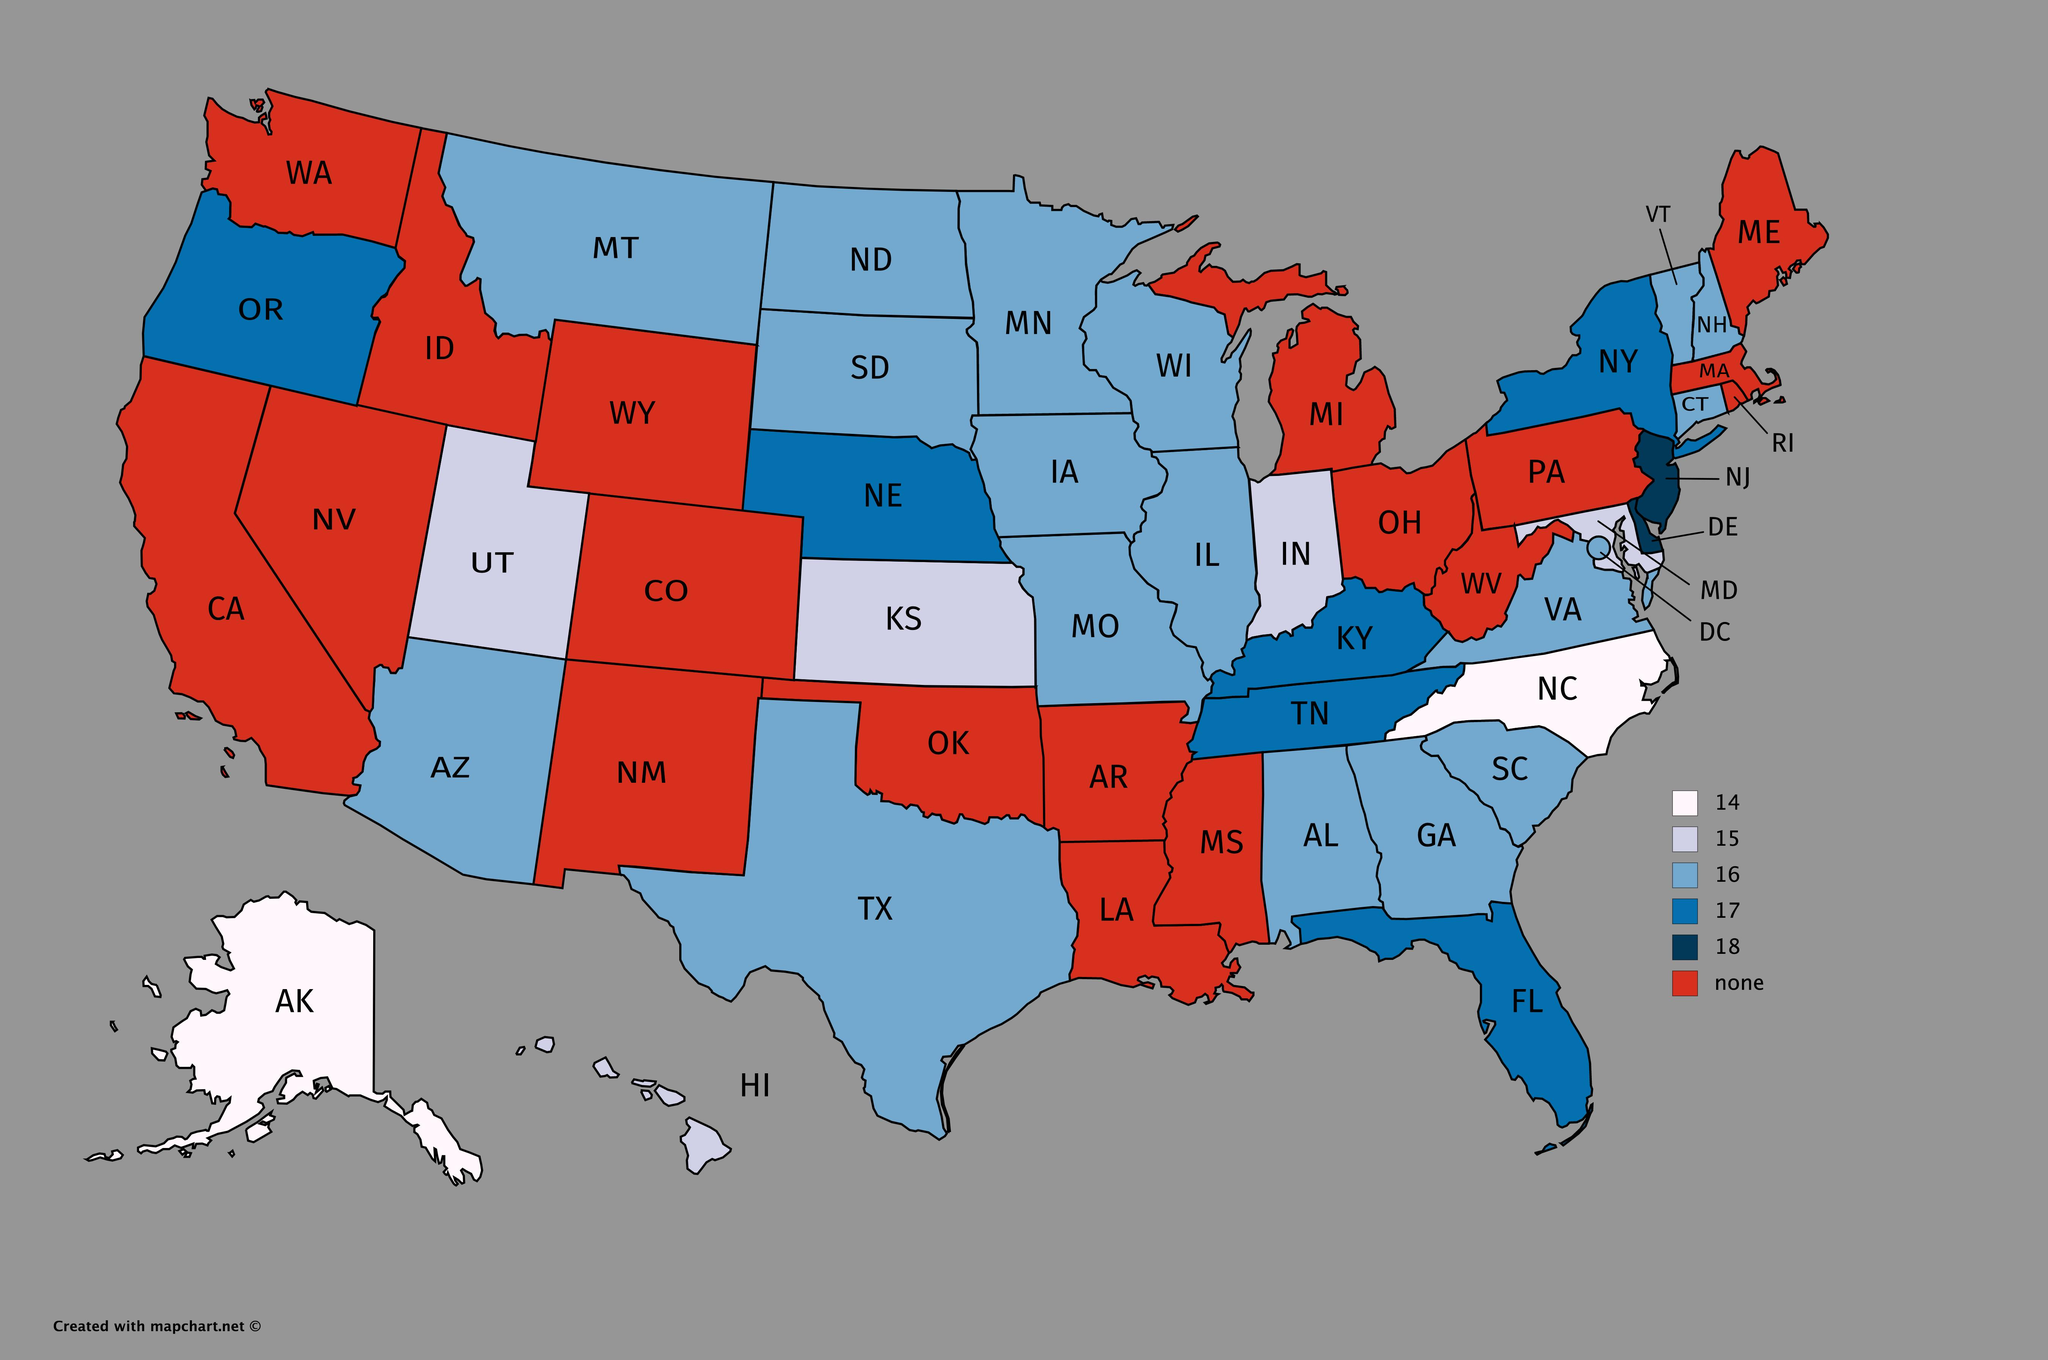Identify some key points in this picture. The map shows 50 states. 